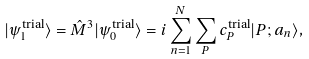Convert formula to latex. <formula><loc_0><loc_0><loc_500><loc_500>| \psi ^ { \text {trial} } _ { 1 } \rangle = \hat { M } ^ { 3 } | \psi ^ { \text {trial} } _ { 0 } \rangle = i \sum _ { n = 1 } ^ { N } \sum _ { P } c _ { P } ^ { \text {trial} } | P ; a _ { n } \rangle ,</formula> 